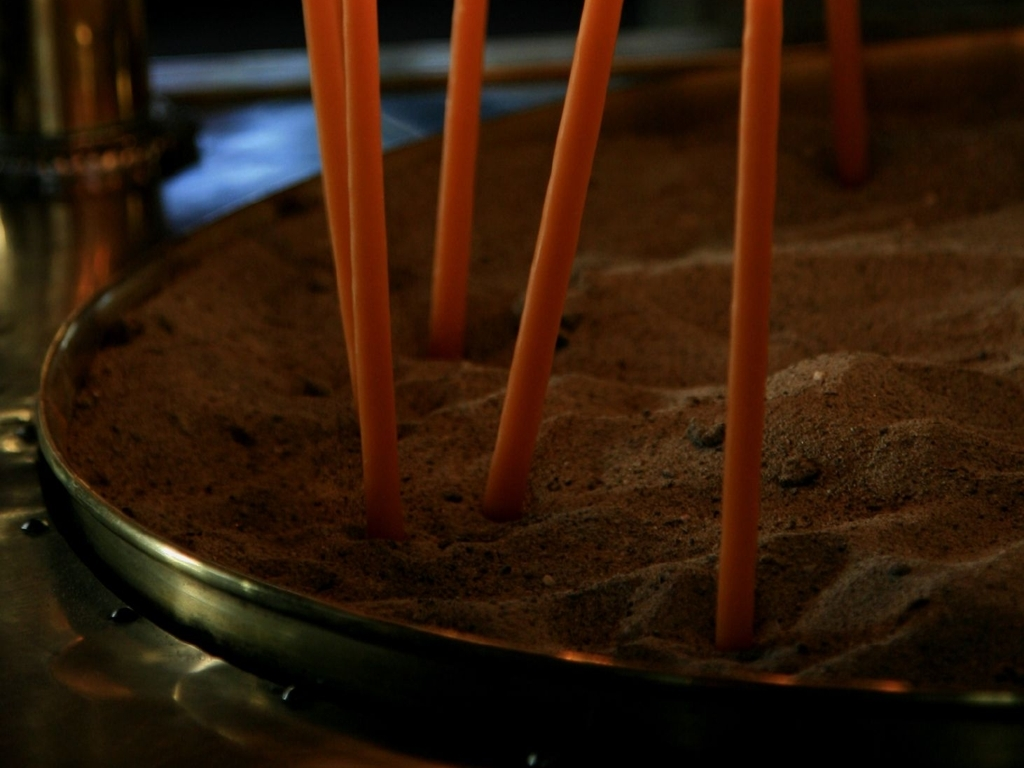What are the color tones in the image? The image predominantly displays warm color tones with a central focus on shades of brown, ranging from dark chocolate to soft sandy hues. These are complemented by the orange tones of the candles, which provide a gentle contrast and add to the overall warmth of the image. 